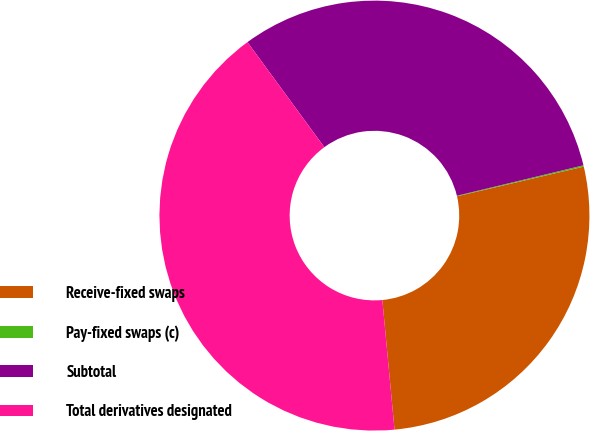Convert chart to OTSL. <chart><loc_0><loc_0><loc_500><loc_500><pie_chart><fcel>Receive-fixed swaps<fcel>Pay-fixed swaps (c)<fcel>Subtotal<fcel>Total derivatives designated<nl><fcel>27.17%<fcel>0.1%<fcel>31.3%<fcel>41.43%<nl></chart> 